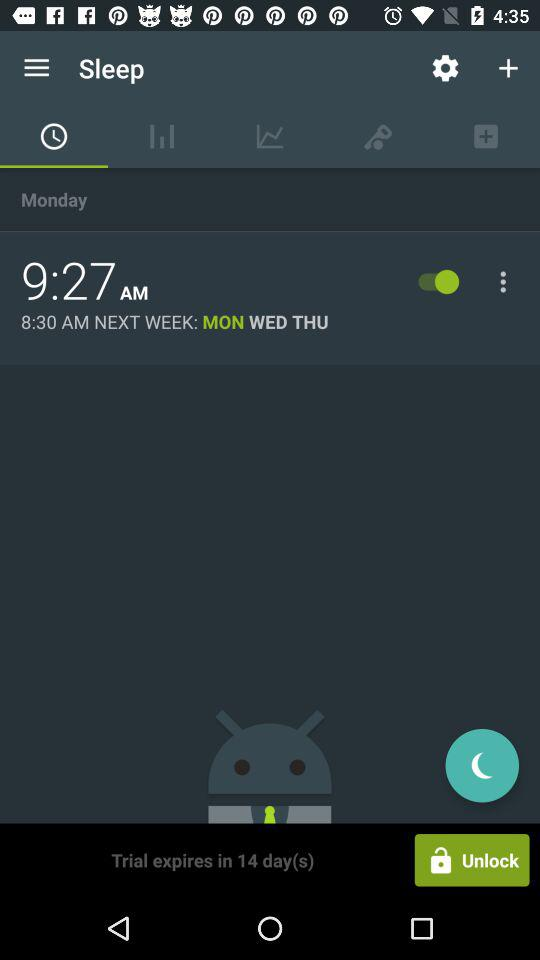What is the current status of the alarm which is scheduled for 9:27 AM? The status is "on". 